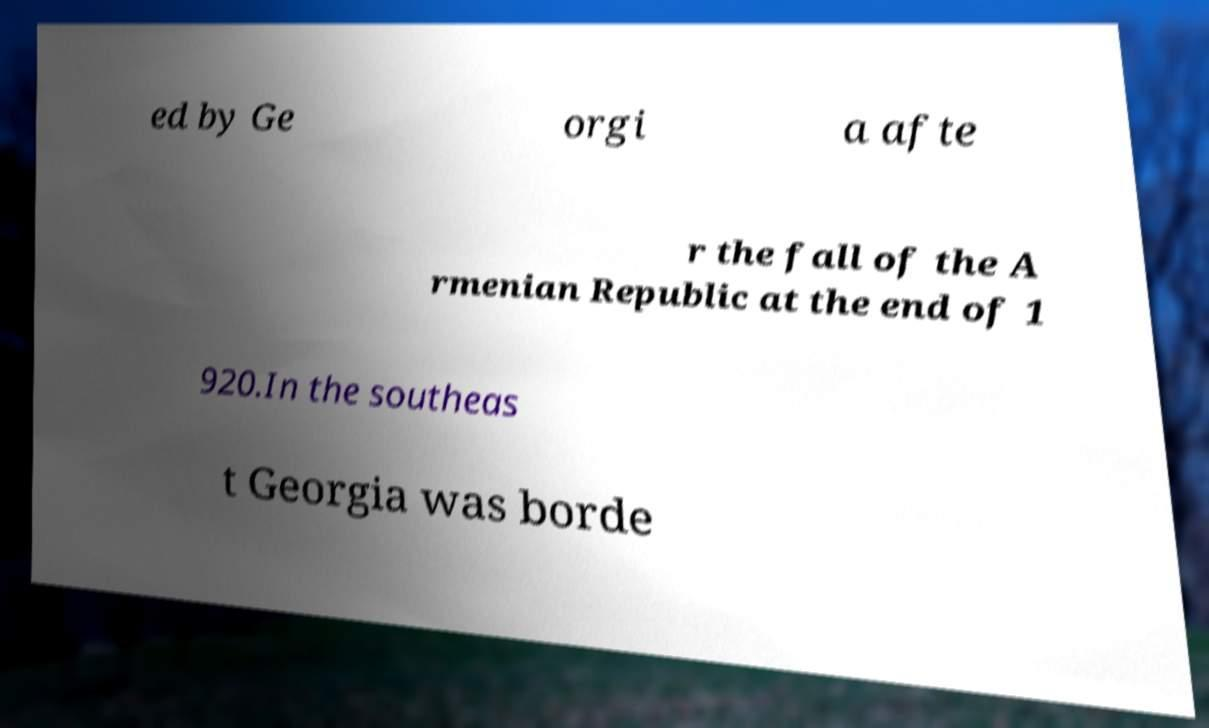Can you read and provide the text displayed in the image?This photo seems to have some interesting text. Can you extract and type it out for me? ed by Ge orgi a afte r the fall of the A rmenian Republic at the end of 1 920.In the southeas t Georgia was borde 